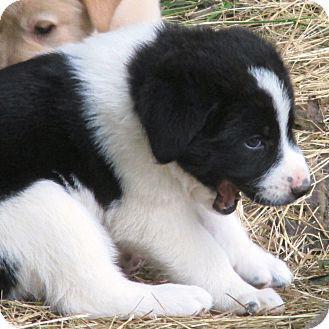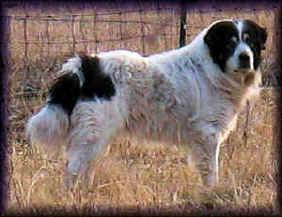The first image is the image on the left, the second image is the image on the right. Considering the images on both sides, is "On of the images contains a young girl in a green sweater with a large white dog." valid? Answer yes or no. No. The first image is the image on the left, the second image is the image on the right. Considering the images on both sides, is "there is a person near a dog in the image on the right side." valid? Answer yes or no. No. 